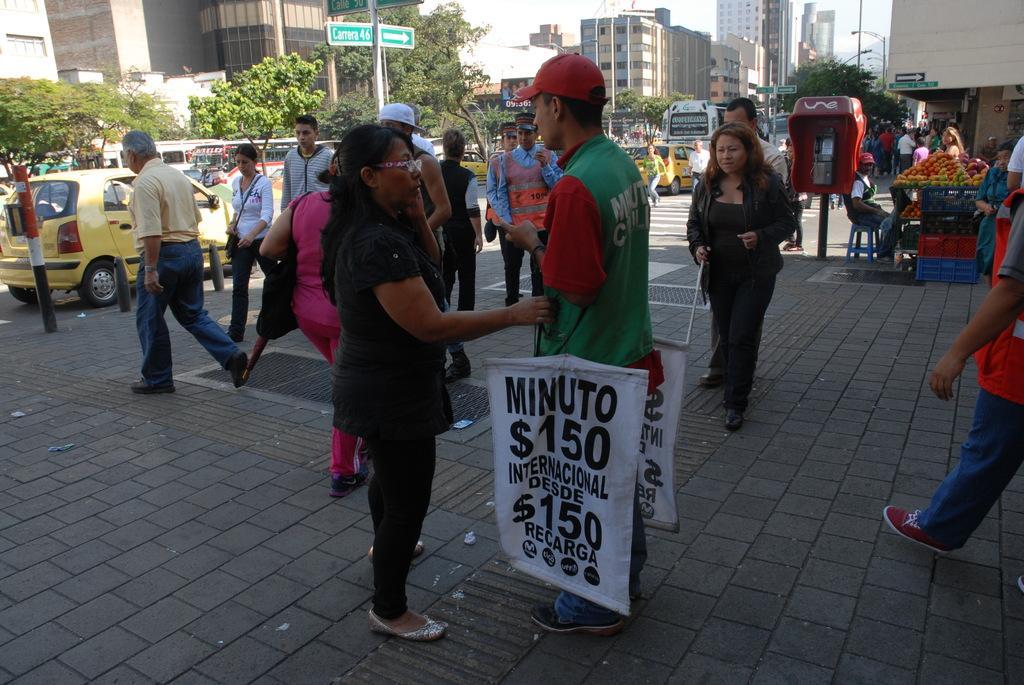How would you summarize this image in a sentence or two? In this image, we can see a group of people. Few are standing and walking. Here we can see banners, poles, buildings, trees, vehicles, sign boards. On the right side of the image, we can see a person is sitting on the stool. 